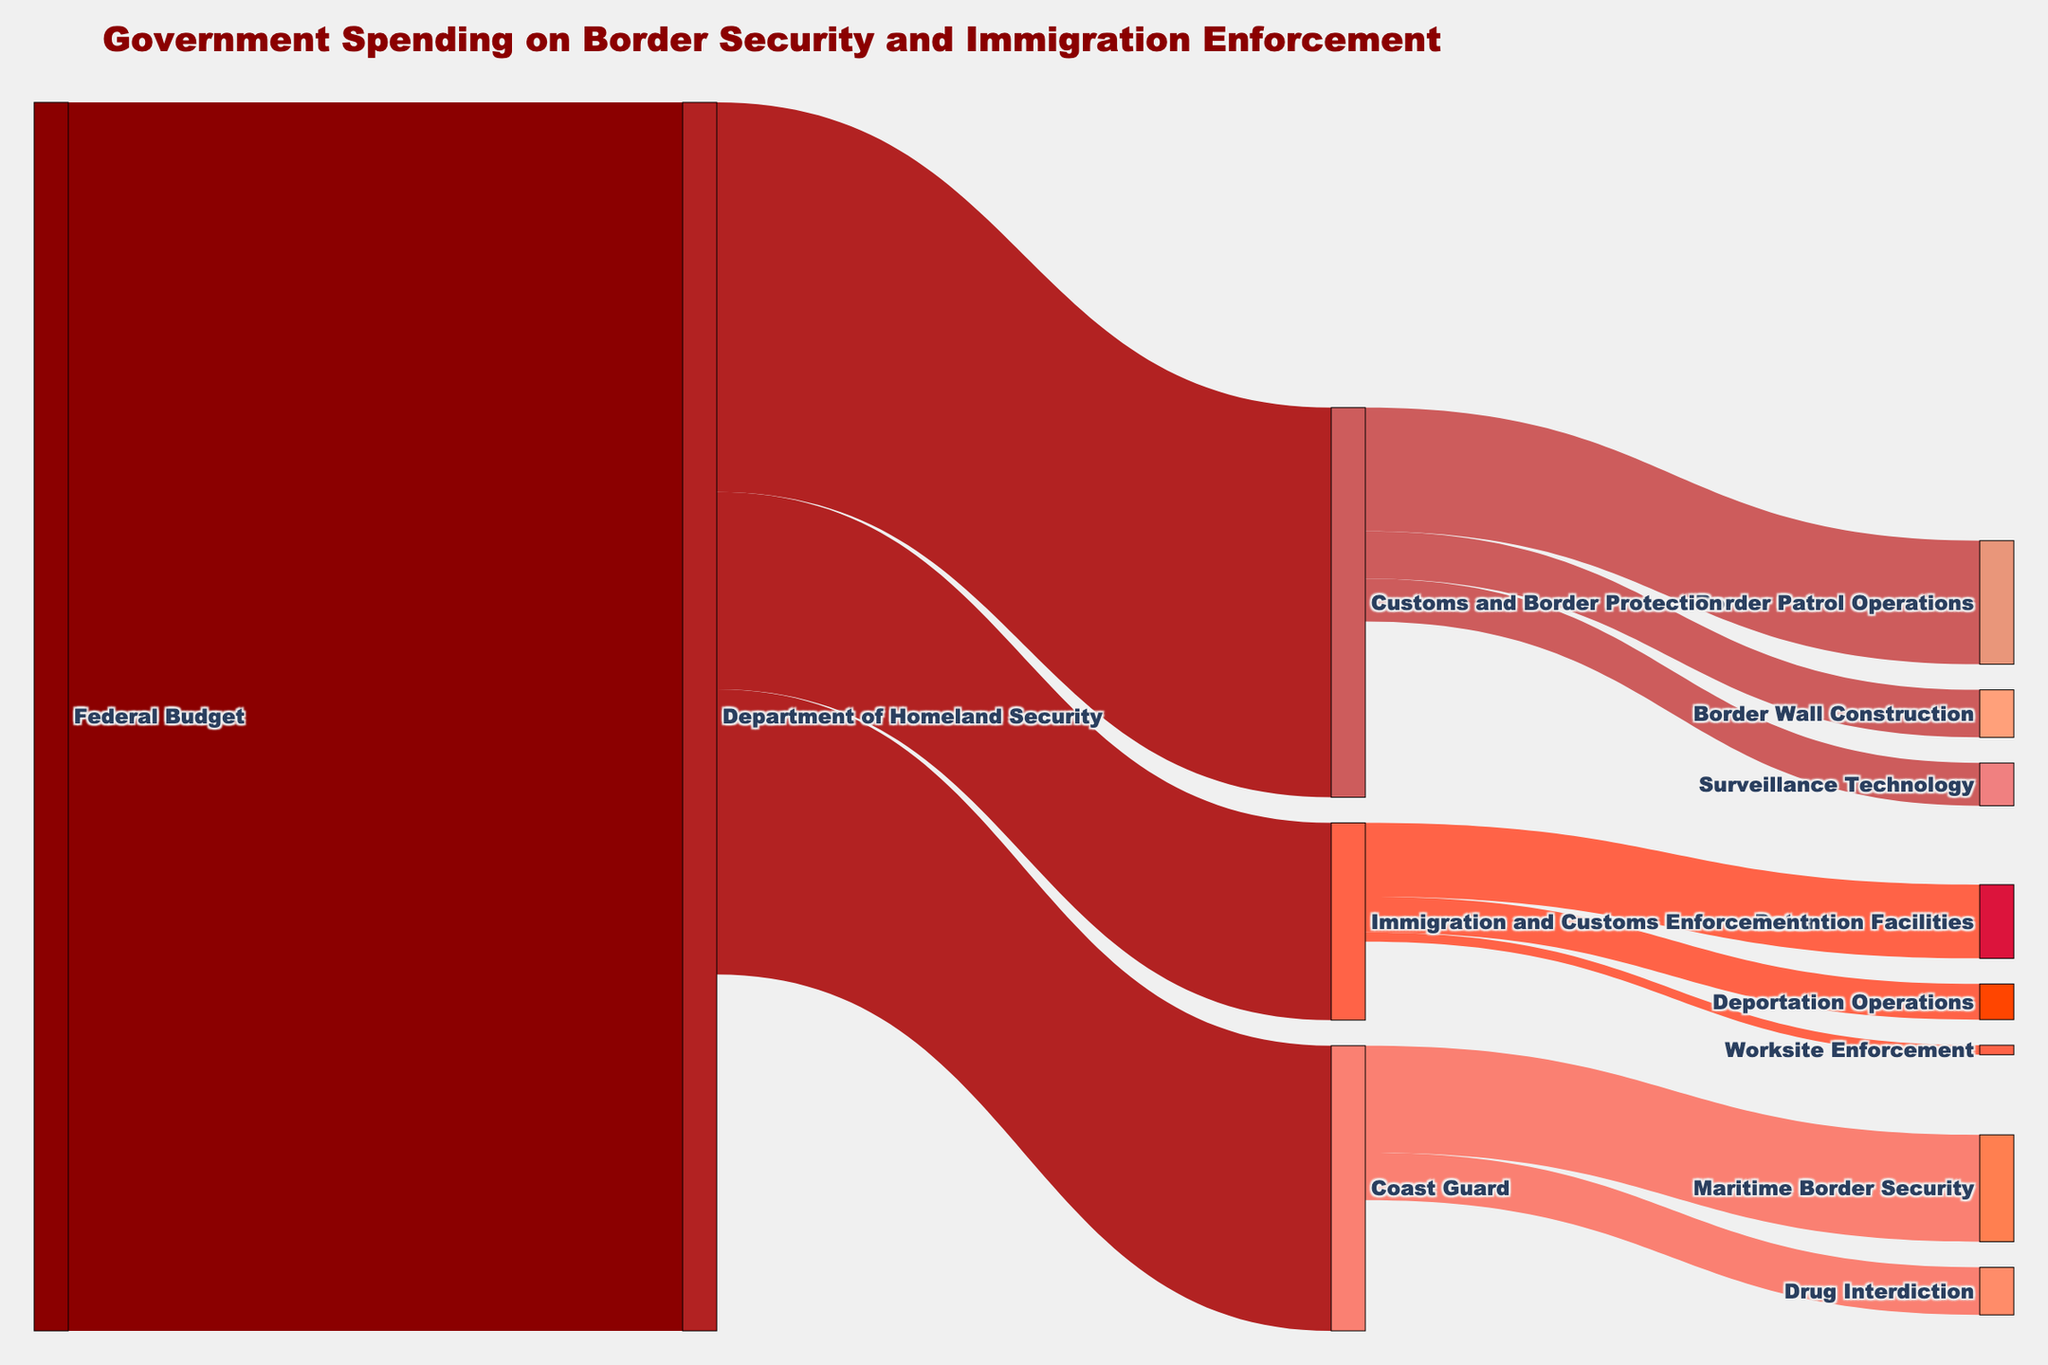What's the title of the figure? The title is often the first element to help understand the main topic of a chart. By looking at the top of the chart, we see the title "Government Spending on Border Security and Immigration Enforcement".
Answer: Government Spending on Border Security and Immigration Enforcement Which department receives the largest allocation from the Federal Budget? We look at the connections from "Federal Budget" and follow the width of the bands. The largest one goes to "Department of Homeland Security" with 51.7 billion dollars.
Answer: Department of Homeland Security How much does Customs and Border Protection receive from the Department of Homeland Security? From "Department of Homeland Security", follow the link to "Customs and Border Protection" and check the value. The value is $16.4 billion.
Answer: 16.4 billion dollars What is the total spending on Immigration and Customs Enforcement? To find the total spending, look at the links from "Department of Homeland Security" to "Immigration and Customs Enforcement", which shows $8.3 billion.
Answer: 8.3 billion dollars Compare the spending on Border Patrol Operations and Surveillance Technology. Which one is higher? Follow the links from "Customs and Border Protection" to "Border Patrol Operations" and "Surveillance Technology" and compare their values. "Border Patrol Operations" has $5.2 billion, which is higher than "Surveillance Technology" at $1.8 billion.
Answer: Border Patrol Operations How much is allocated to coast guard activities? Sum the values from "Coast Guard" to its activities: "Maritime Border Security" ($4.5 billion) and "Drug Interdiction" ($2 billion). Total = 4.5 + 2 = 6.5 billion dollars.
Answer: 6.5 billion dollars What is the combined spending on Detention Facilities and Deportation Operations? Follow the links from "Immigration and Customs Enforcement" to "Detention Facilities" ($3.1 billion) and "Deportation Operations" ($1.5 billion). Sum them up: 3.1 + 1.5 = 4.6 billion dollars.
Answer: 4.6 billion dollars What portion of the Customs and Border Protection budget goes to Border Wall Construction? Divide the value for "Border Wall Construction" ($2 billion) by the total value for "Customs and Border Protection" ($16.4 billion) and multiply by 100 to get the percentage. (2/16.4) * 100 ≈ 12.2%.
Answer: 12.2% How does the spending on Drug Interdiction compare to Surveillance Technology? Compare the values directly: "Drug Interdiction" ($2 billion) versus "Surveillance Technology" ($1.8 billion). Drug Interdiction is slightly higher.
Answer: Drug Interdiction What is the smallest allocation within the Department of Homeland Security? Look at all the targets connected to "Department of Homeland Security" and find the smallest value. "Worksite Enforcement" has the smallest allocation with $400 million.
Answer: Worksite Enforcement 